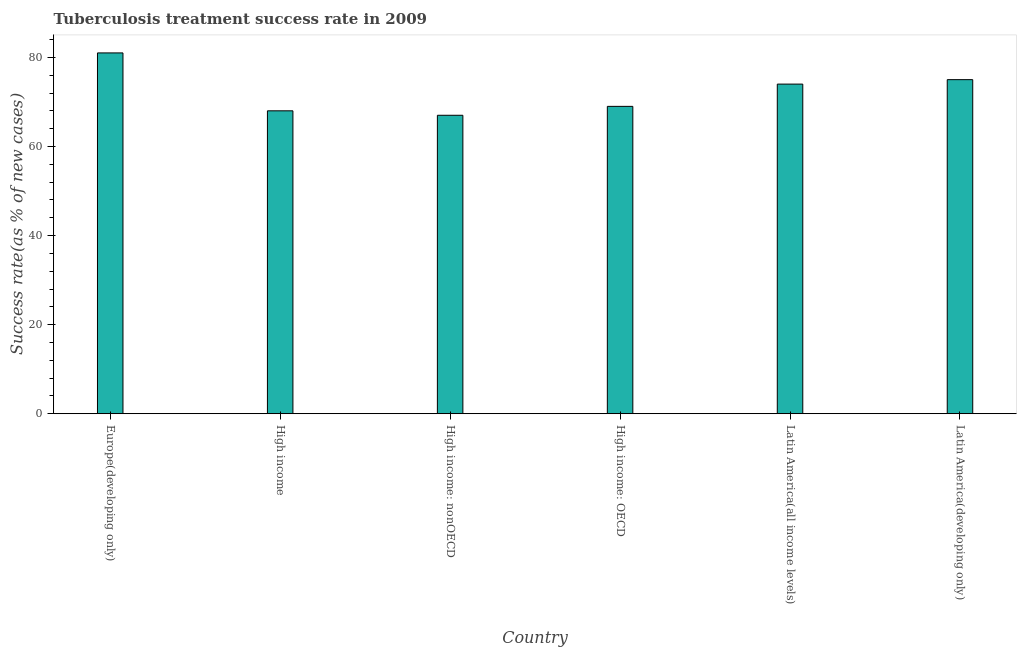Does the graph contain any zero values?
Offer a terse response. No. What is the title of the graph?
Keep it short and to the point. Tuberculosis treatment success rate in 2009. What is the label or title of the X-axis?
Ensure brevity in your answer.  Country. What is the label or title of the Y-axis?
Make the answer very short. Success rate(as % of new cases). Across all countries, what is the maximum tuberculosis treatment success rate?
Provide a succinct answer. 81. Across all countries, what is the minimum tuberculosis treatment success rate?
Keep it short and to the point. 67. In which country was the tuberculosis treatment success rate maximum?
Give a very brief answer. Europe(developing only). In which country was the tuberculosis treatment success rate minimum?
Provide a succinct answer. High income: nonOECD. What is the sum of the tuberculosis treatment success rate?
Give a very brief answer. 434. What is the median tuberculosis treatment success rate?
Offer a terse response. 71.5. In how many countries, is the tuberculosis treatment success rate greater than 72 %?
Offer a very short reply. 3. What is the ratio of the tuberculosis treatment success rate in High income to that in High income: nonOECD?
Provide a short and direct response. 1.01. Is the tuberculosis treatment success rate in High income less than that in High income: nonOECD?
Offer a very short reply. No. What is the difference between the highest and the second highest tuberculosis treatment success rate?
Offer a very short reply. 6. In how many countries, is the tuberculosis treatment success rate greater than the average tuberculosis treatment success rate taken over all countries?
Ensure brevity in your answer.  3. How many bars are there?
Your answer should be compact. 6. What is the difference between two consecutive major ticks on the Y-axis?
Give a very brief answer. 20. Are the values on the major ticks of Y-axis written in scientific E-notation?
Keep it short and to the point. No. What is the Success rate(as % of new cases) in Europe(developing only)?
Your response must be concise. 81. What is the Success rate(as % of new cases) of High income: nonOECD?
Provide a succinct answer. 67. What is the difference between the Success rate(as % of new cases) in Europe(developing only) and High income?
Offer a very short reply. 13. What is the difference between the Success rate(as % of new cases) in Europe(developing only) and High income: OECD?
Ensure brevity in your answer.  12. What is the difference between the Success rate(as % of new cases) in High income and High income: nonOECD?
Ensure brevity in your answer.  1. What is the difference between the Success rate(as % of new cases) in High income: nonOECD and High income: OECD?
Make the answer very short. -2. What is the difference between the Success rate(as % of new cases) in High income: nonOECD and Latin America(all income levels)?
Make the answer very short. -7. What is the difference between the Success rate(as % of new cases) in High income: nonOECD and Latin America(developing only)?
Ensure brevity in your answer.  -8. What is the difference between the Success rate(as % of new cases) in High income: OECD and Latin America(all income levels)?
Give a very brief answer. -5. What is the difference between the Success rate(as % of new cases) in High income: OECD and Latin America(developing only)?
Ensure brevity in your answer.  -6. What is the difference between the Success rate(as % of new cases) in Latin America(all income levels) and Latin America(developing only)?
Offer a very short reply. -1. What is the ratio of the Success rate(as % of new cases) in Europe(developing only) to that in High income?
Ensure brevity in your answer.  1.19. What is the ratio of the Success rate(as % of new cases) in Europe(developing only) to that in High income: nonOECD?
Make the answer very short. 1.21. What is the ratio of the Success rate(as % of new cases) in Europe(developing only) to that in High income: OECD?
Make the answer very short. 1.17. What is the ratio of the Success rate(as % of new cases) in Europe(developing only) to that in Latin America(all income levels)?
Ensure brevity in your answer.  1.09. What is the ratio of the Success rate(as % of new cases) in High income to that in High income: OECD?
Offer a very short reply. 0.99. What is the ratio of the Success rate(as % of new cases) in High income to that in Latin America(all income levels)?
Make the answer very short. 0.92. What is the ratio of the Success rate(as % of new cases) in High income to that in Latin America(developing only)?
Your answer should be compact. 0.91. What is the ratio of the Success rate(as % of new cases) in High income: nonOECD to that in Latin America(all income levels)?
Your answer should be very brief. 0.91. What is the ratio of the Success rate(as % of new cases) in High income: nonOECD to that in Latin America(developing only)?
Ensure brevity in your answer.  0.89. What is the ratio of the Success rate(as % of new cases) in High income: OECD to that in Latin America(all income levels)?
Provide a succinct answer. 0.93. What is the ratio of the Success rate(as % of new cases) in Latin America(all income levels) to that in Latin America(developing only)?
Offer a very short reply. 0.99. 